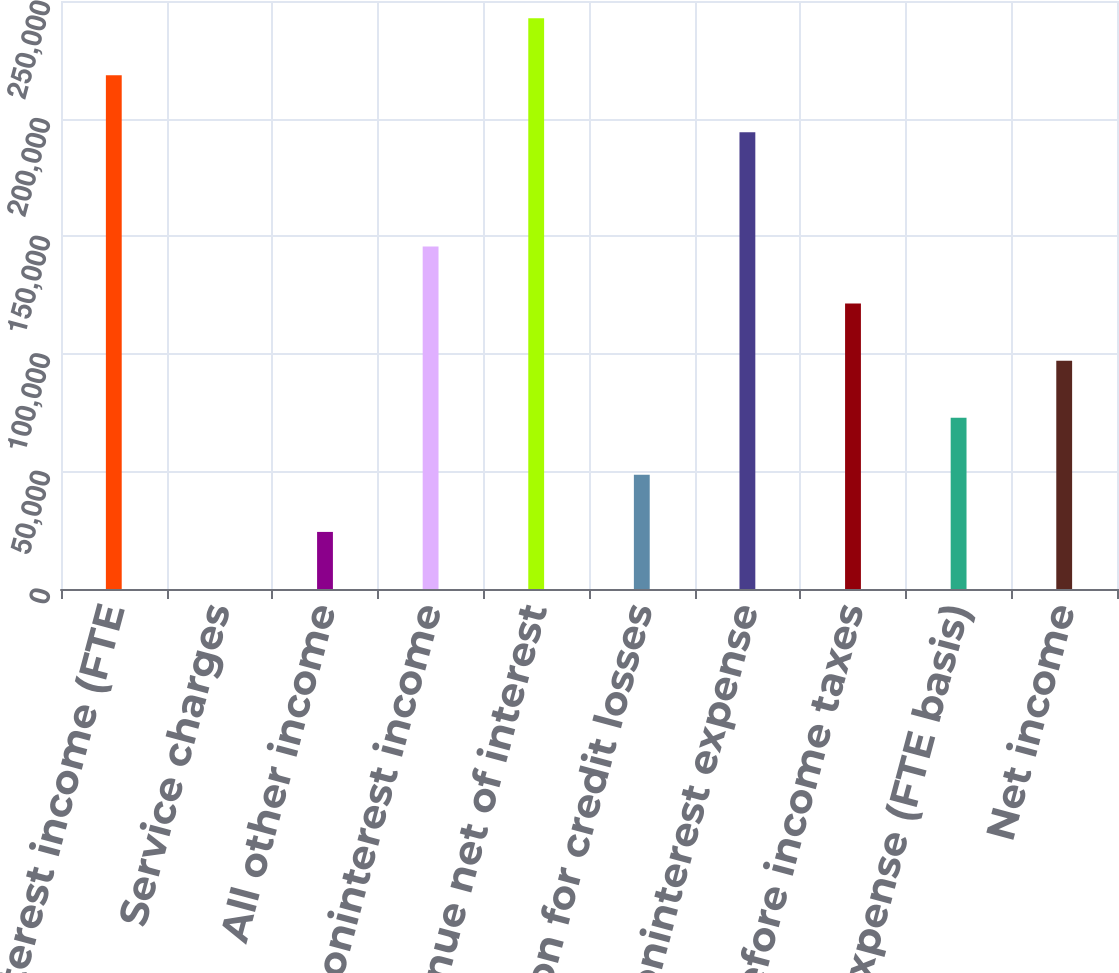Convert chart. <chart><loc_0><loc_0><loc_500><loc_500><bar_chart><fcel>Net interest income (FTE<fcel>Service charges<fcel>All other income<fcel>Total noninterest income<fcel>Total revenue net of interest<fcel>Provision for credit losses<fcel>Noninterest expense<fcel>Income before income taxes<fcel>Income tax expense (FTE basis)<fcel>Net income<nl><fcel>218436<fcel>1<fcel>24271.6<fcel>145625<fcel>242707<fcel>48542.2<fcel>194166<fcel>121354<fcel>72812.8<fcel>97083.4<nl></chart> 